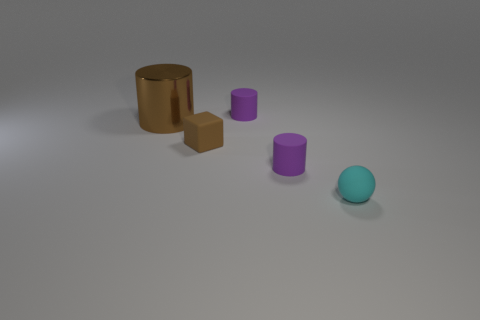What number of things are tiny objects on the left side of the small cyan object or objects to the left of the tiny cyan object?
Offer a very short reply. 4. Is the size of the ball the same as the brown rubber object?
Your answer should be compact. Yes. How many blocks are either big brown shiny objects or brown objects?
Offer a terse response. 1. What number of tiny things are both behind the tiny cyan rubber thing and in front of the tiny brown block?
Ensure brevity in your answer.  1. There is a brown cylinder; is it the same size as the cylinder in front of the tiny brown matte object?
Your answer should be very brief. No. Are there any large shiny cylinders in front of the tiny cylinder right of the small cylinder that is behind the small block?
Your answer should be compact. No. The cylinder to the left of the small purple cylinder that is behind the big object is made of what material?
Ensure brevity in your answer.  Metal. What material is the cylinder that is behind the small brown matte object and to the right of the small brown rubber object?
Give a very brief answer. Rubber. Is there a small gray thing that has the same shape as the small cyan rubber thing?
Your answer should be very brief. No. Are there any objects that are behind the tiny cylinder behind the small brown cube?
Ensure brevity in your answer.  No. 